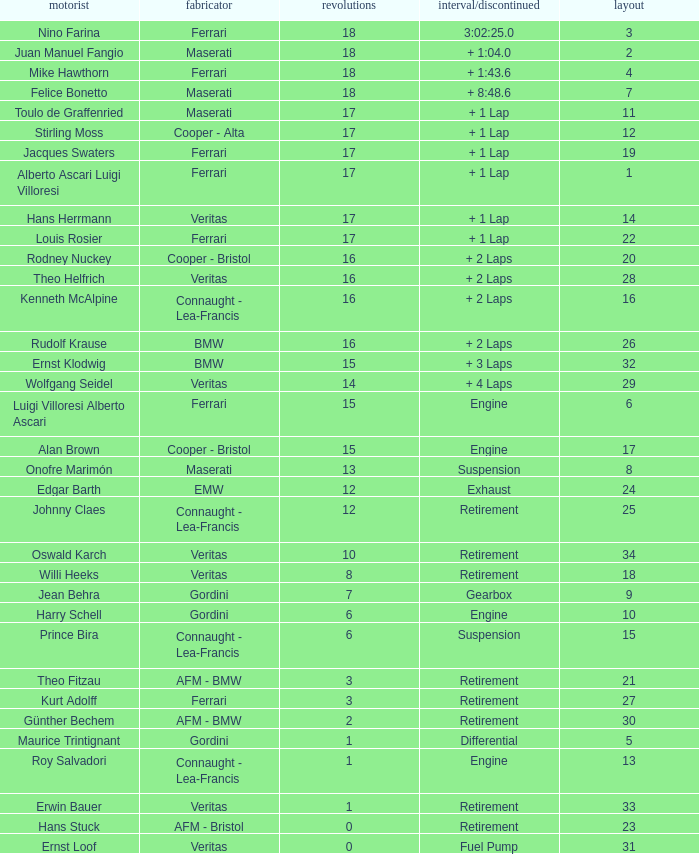Who has the low lap total in a maserati with grid 2? 18.0. 